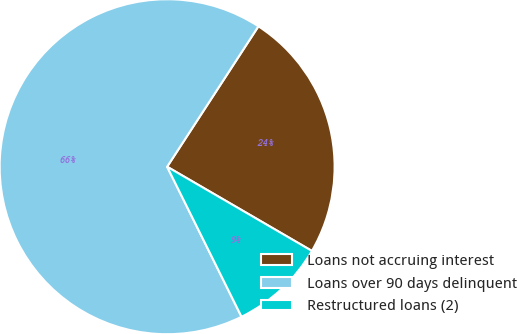Convert chart to OTSL. <chart><loc_0><loc_0><loc_500><loc_500><pie_chart><fcel>Loans not accruing interest<fcel>Loans over 90 days delinquent<fcel>Restructured loans (2)<nl><fcel>24.21%<fcel>66.5%<fcel>9.29%<nl></chart> 